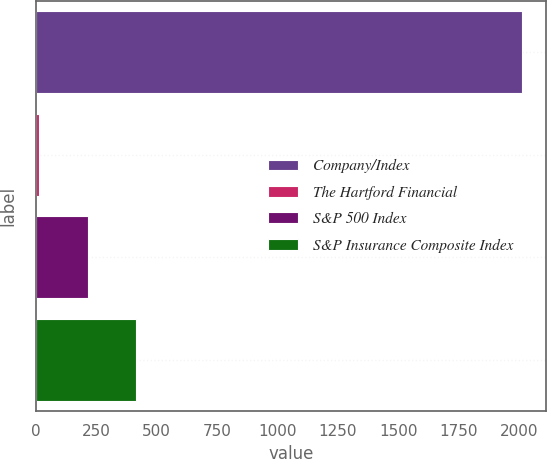<chart> <loc_0><loc_0><loc_500><loc_500><bar_chart><fcel>Company/Index<fcel>The Hartford Financial<fcel>S&P 500 Index<fcel>S&P Insurance Composite Index<nl><fcel>2010<fcel>14.89<fcel>214.4<fcel>413.91<nl></chart> 